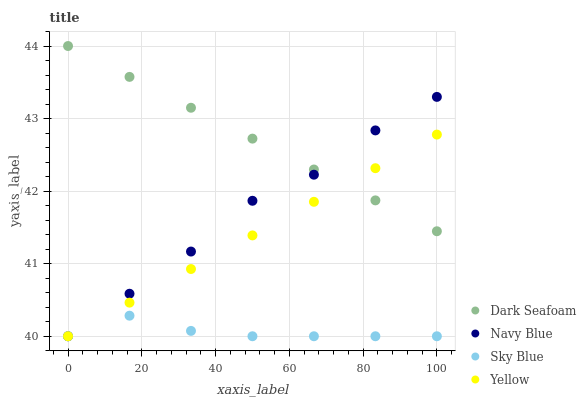Does Sky Blue have the minimum area under the curve?
Answer yes or no. Yes. Does Dark Seafoam have the maximum area under the curve?
Answer yes or no. Yes. Does Yellow have the minimum area under the curve?
Answer yes or no. No. Does Yellow have the maximum area under the curve?
Answer yes or no. No. Is Dark Seafoam the smoothest?
Answer yes or no. Yes. Is Navy Blue the roughest?
Answer yes or no. Yes. Is Yellow the smoothest?
Answer yes or no. No. Is Yellow the roughest?
Answer yes or no. No. Does Navy Blue have the lowest value?
Answer yes or no. Yes. Does Dark Seafoam have the lowest value?
Answer yes or no. No. Does Dark Seafoam have the highest value?
Answer yes or no. Yes. Does Yellow have the highest value?
Answer yes or no. No. Is Sky Blue less than Dark Seafoam?
Answer yes or no. Yes. Is Dark Seafoam greater than Sky Blue?
Answer yes or no. Yes. Does Sky Blue intersect Navy Blue?
Answer yes or no. Yes. Is Sky Blue less than Navy Blue?
Answer yes or no. No. Is Sky Blue greater than Navy Blue?
Answer yes or no. No. Does Sky Blue intersect Dark Seafoam?
Answer yes or no. No. 